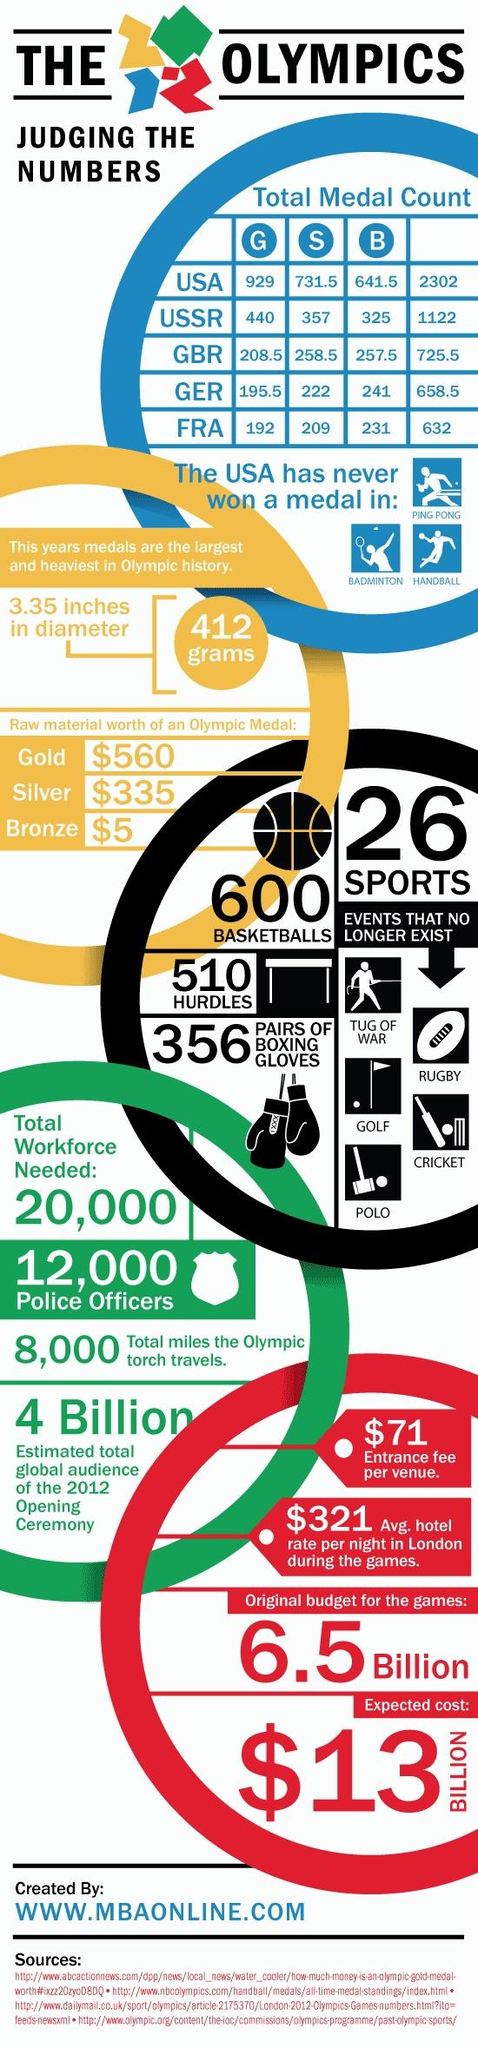Draw attention to some important aspects in this diagram. The raw material value of a gold Olympic medal is $560. The raw material value of a bronze Olympic medal is approximately $5. There are 26 sports included in the Olympic Games. The entrance fee for the 2012 Olympic opening ceremony was $71 per person. The Olympic torch has traveled a total of 8,000 miles. 